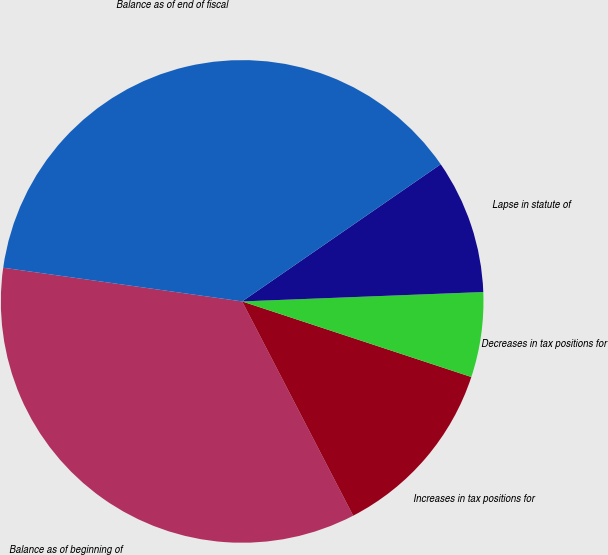<chart> <loc_0><loc_0><loc_500><loc_500><pie_chart><fcel>Balance as of beginning of<fcel>Increases in tax positions for<fcel>Decreases in tax positions for<fcel>Lapse in statute of<fcel>Balance as of end of fiscal<nl><fcel>34.84%<fcel>12.32%<fcel>5.69%<fcel>9.0%<fcel>38.15%<nl></chart> 